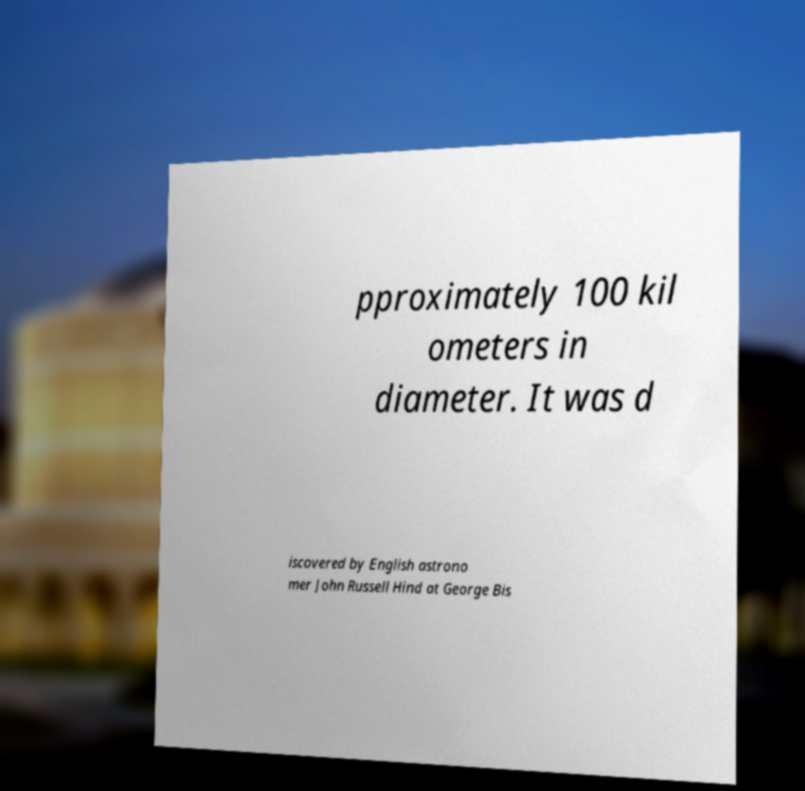There's text embedded in this image that I need extracted. Can you transcribe it verbatim? pproximately 100 kil ometers in diameter. It was d iscovered by English astrono mer John Russell Hind at George Bis 